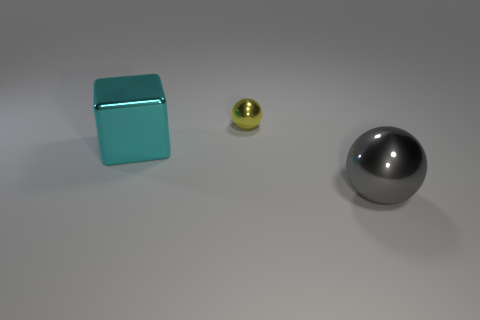Add 3 small green spheres. How many objects exist? 6 Subtract all blocks. How many objects are left? 2 Subtract 0 cyan balls. How many objects are left? 3 Subtract all big yellow metal cylinders. Subtract all cyan metal things. How many objects are left? 2 Add 2 small yellow metal balls. How many small yellow metal balls are left? 3 Add 3 big cyan metal objects. How many big cyan metal objects exist? 4 